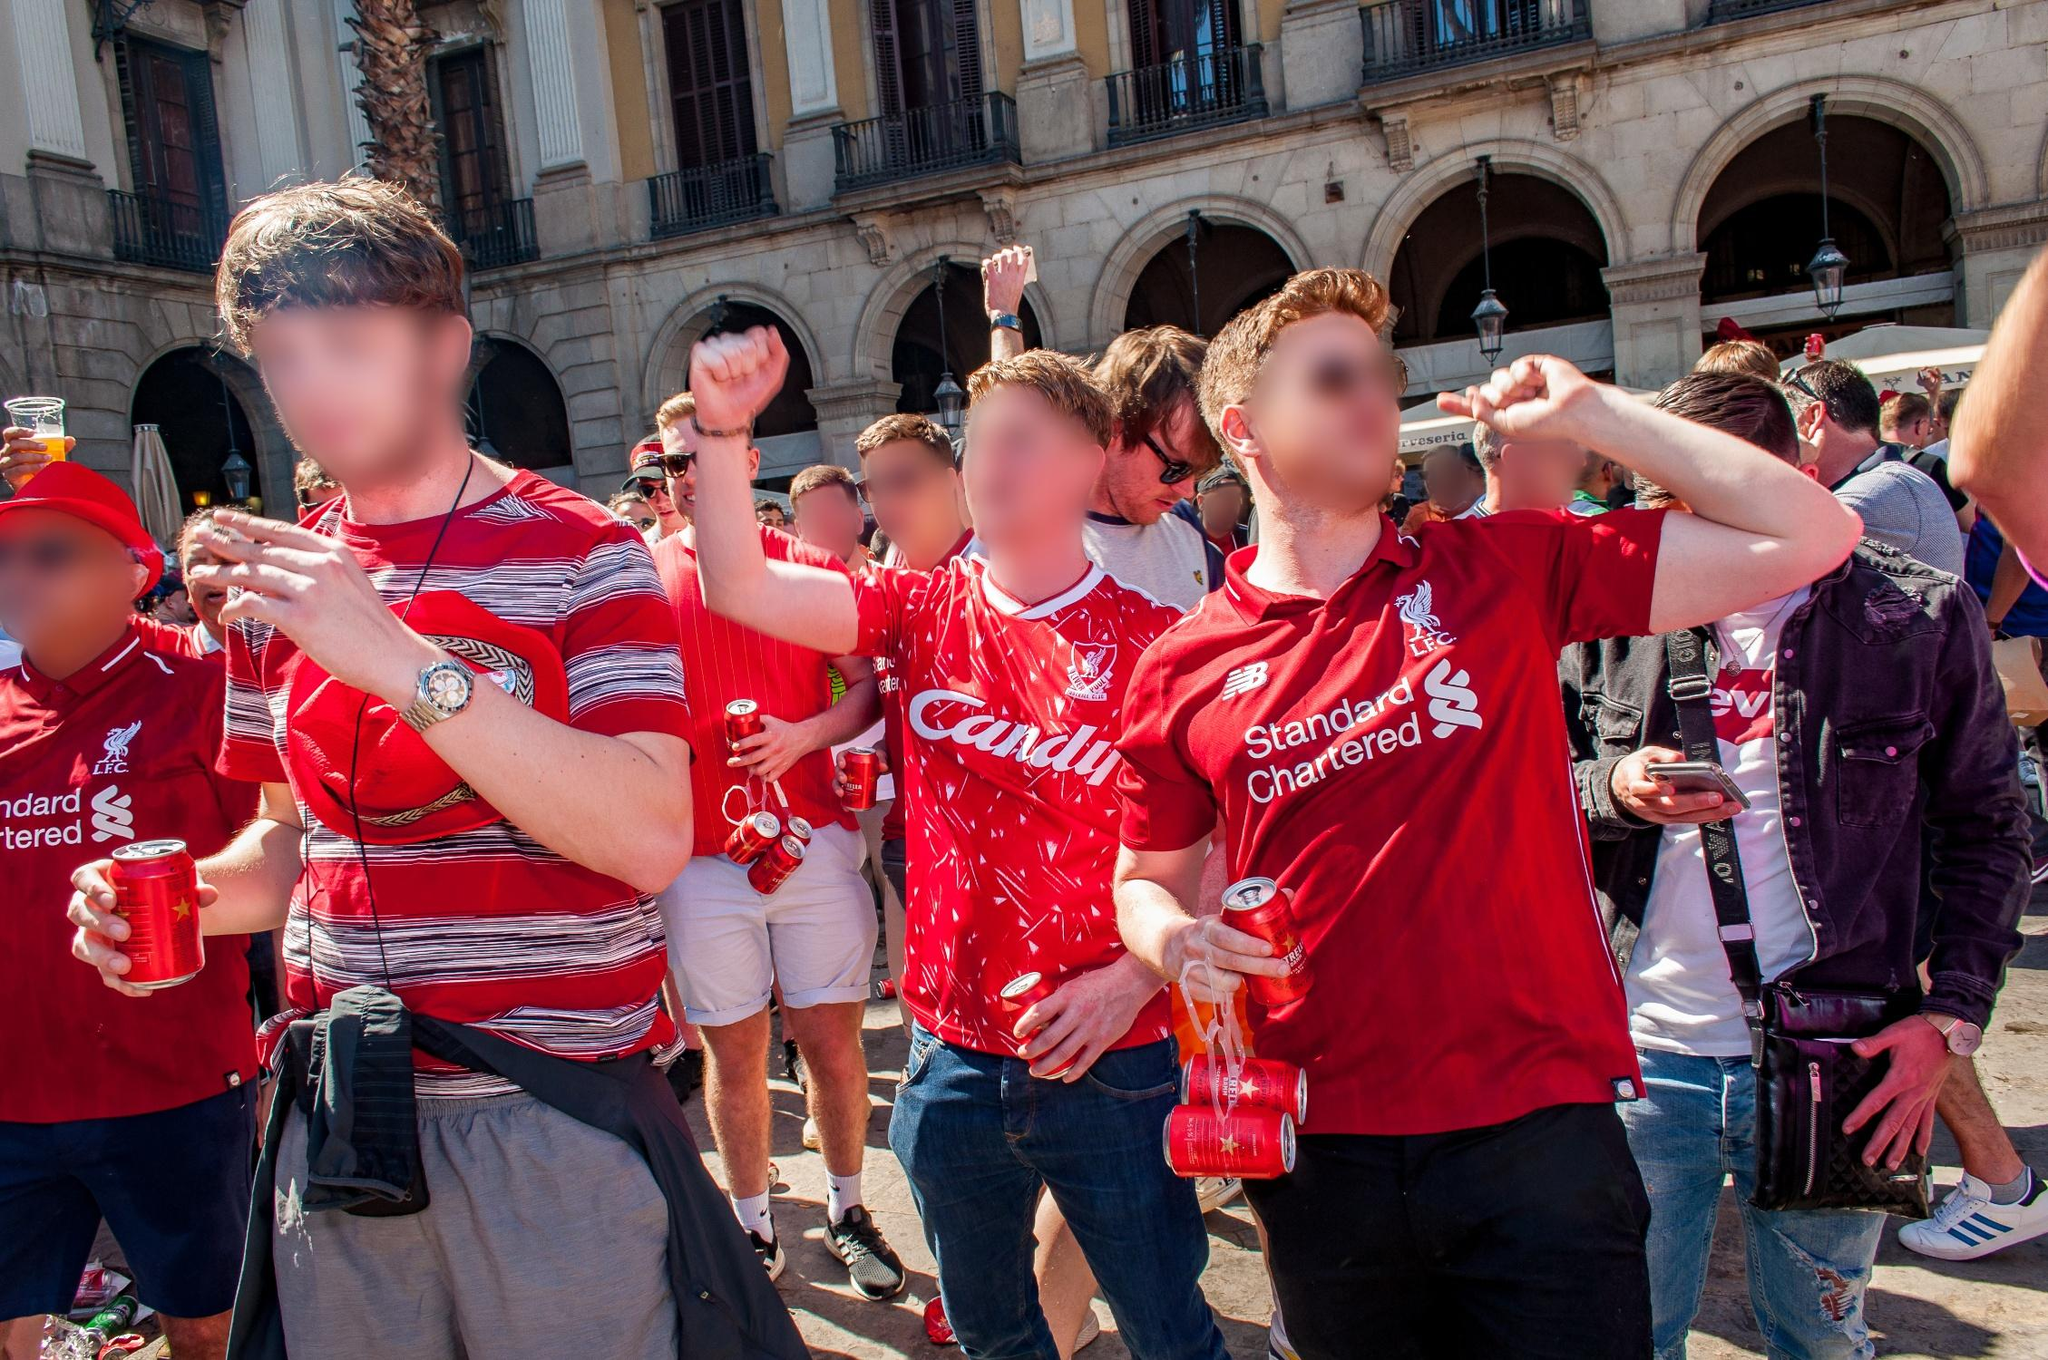Can you describe the mood of the people in this photo? The mood of the people in the photo is one of joyous celebration and high spirits. They are all smiling, cheering, and holding up drinks, suggesting that they are in a festive and exuberant state of mind. The bright daylight and the grand setting of the historic building further amplify the lively and upbeat atmosphere. 